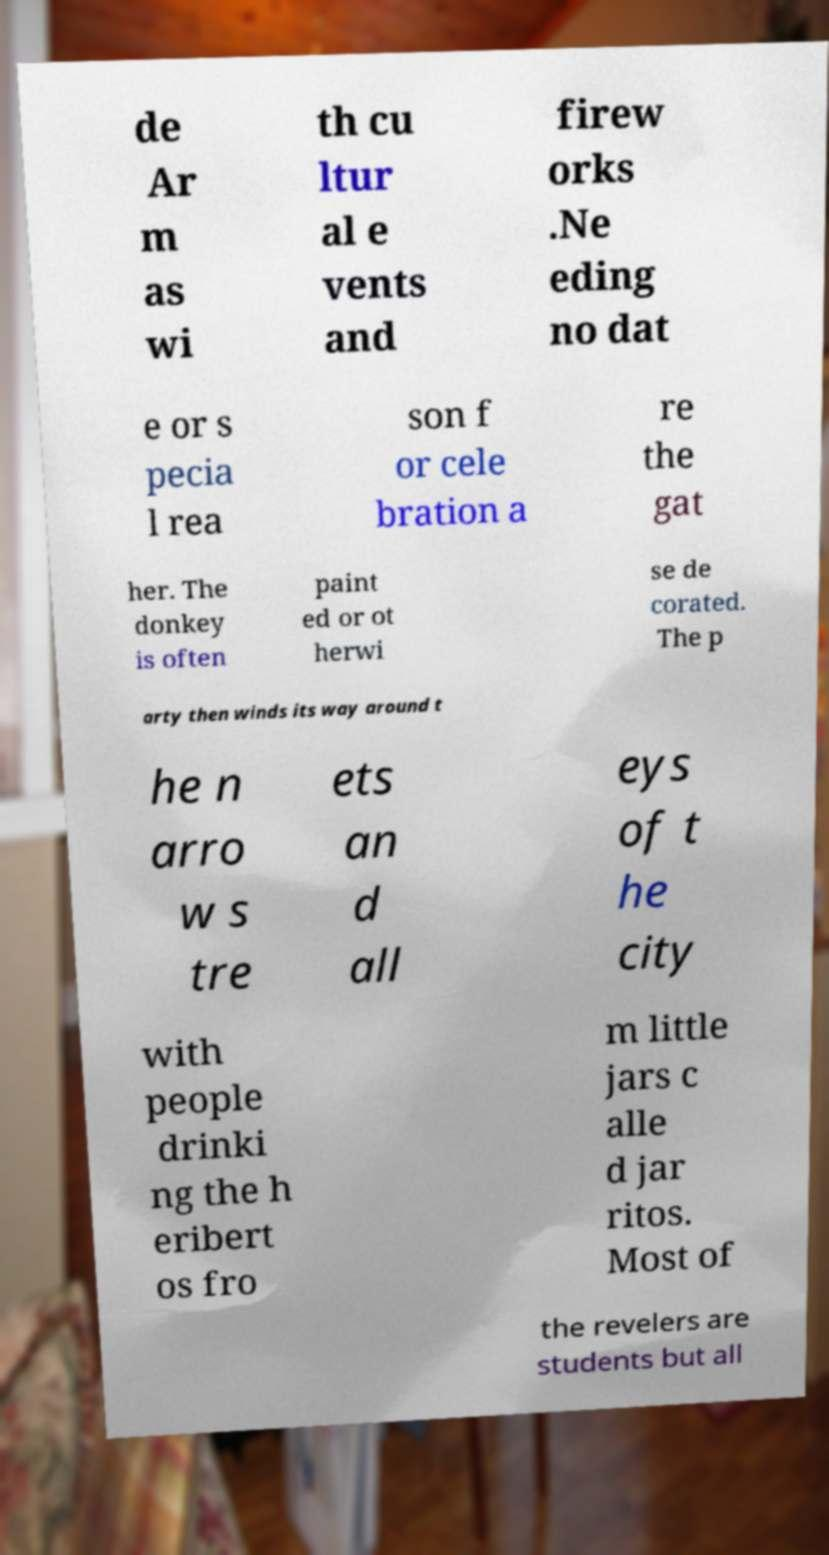Could you assist in decoding the text presented in this image and type it out clearly? de Ar m as wi th cu ltur al e vents and firew orks .Ne eding no dat e or s pecia l rea son f or cele bration a re the gat her. The donkey is often paint ed or ot herwi se de corated. The p arty then winds its way around t he n arro w s tre ets an d all eys of t he city with people drinki ng the h eribert os fro m little jars c alle d jar ritos. Most of the revelers are students but all 